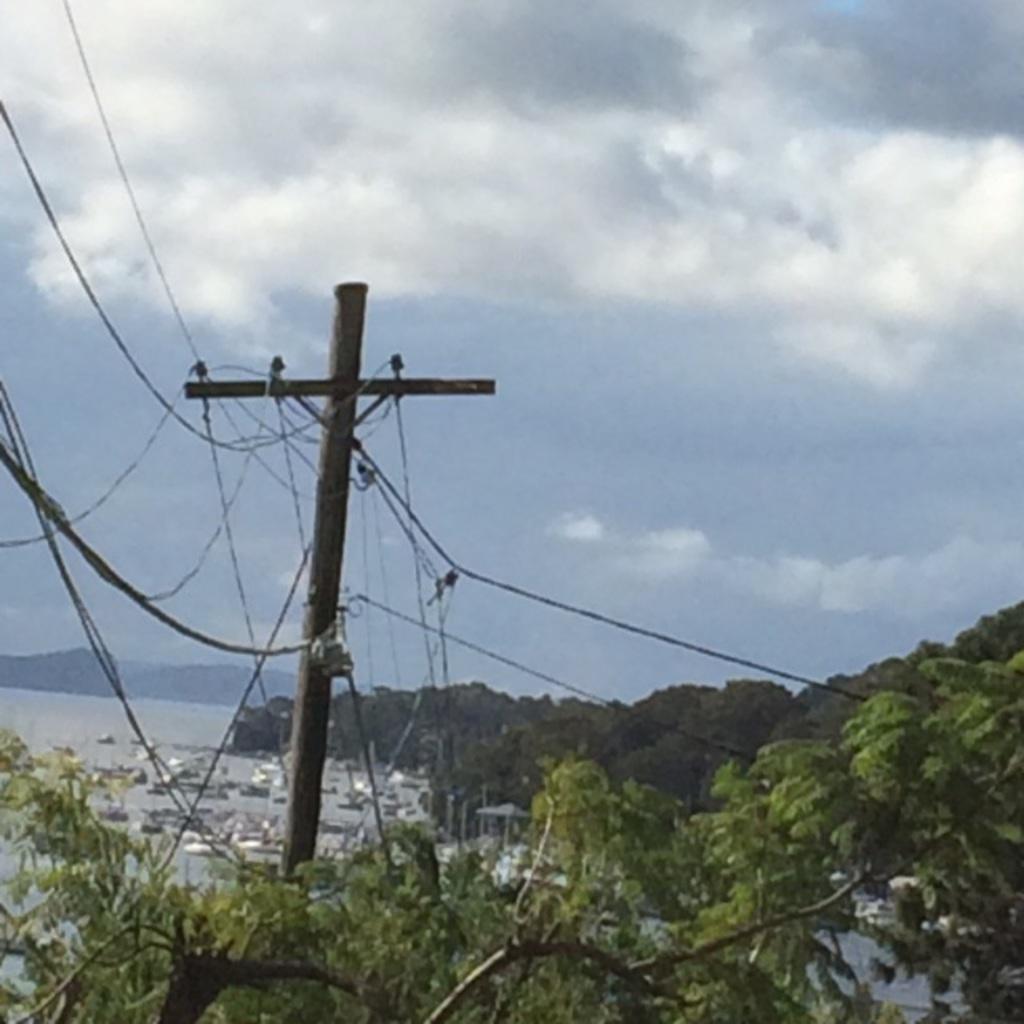Describe this image in one or two sentences. In this image I can see the current pole. To the right there are many trees. To the left I can see some boats on the water. In the background I can see the mountains, clouds and the sky. 